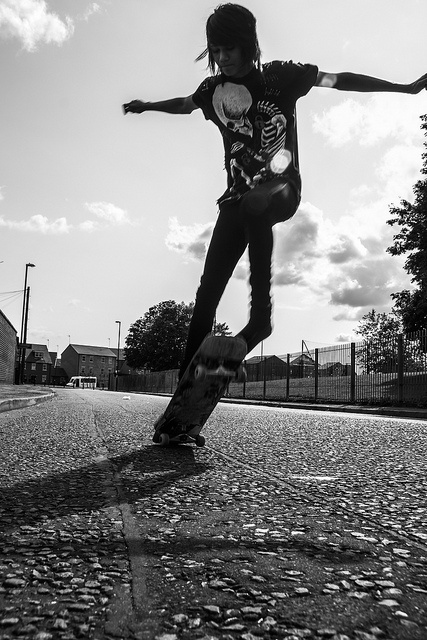Describe the objects in this image and their specific colors. I can see people in lightgray, black, gray, and darkgray tones, skateboard in lightgray, black, gray, and darkgray tones, and bus in lightgray, black, gray, and darkgray tones in this image. 